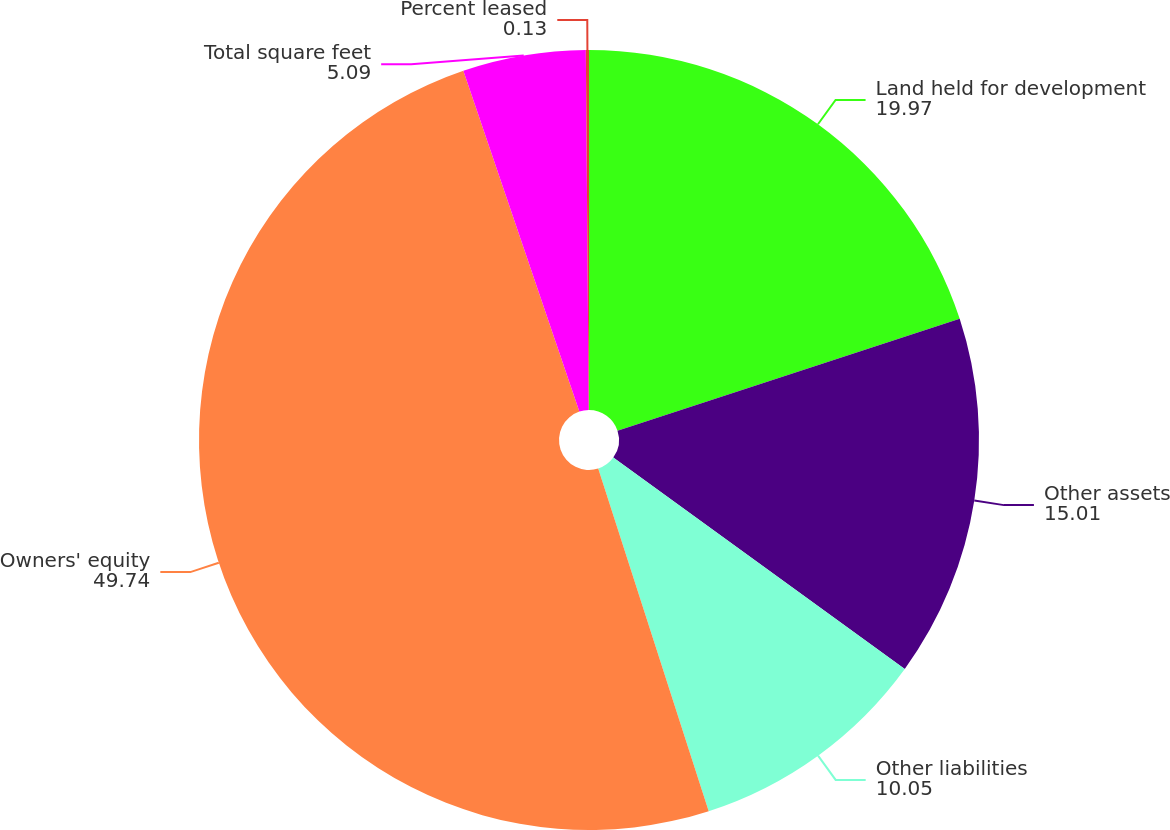<chart> <loc_0><loc_0><loc_500><loc_500><pie_chart><fcel>Land held for development<fcel>Other assets<fcel>Other liabilities<fcel>Owners' equity<fcel>Total square feet<fcel>Percent leased<nl><fcel>19.97%<fcel>15.01%<fcel>10.05%<fcel>49.74%<fcel>5.09%<fcel>0.13%<nl></chart> 